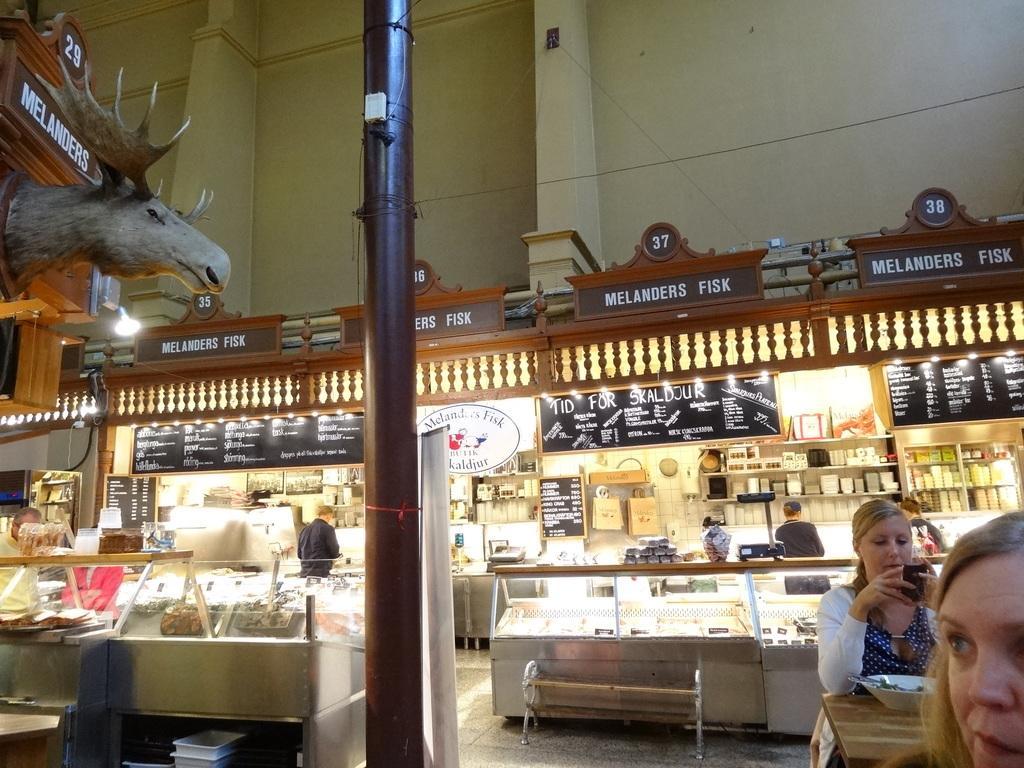Describe this image in one or two sentences. In this image I see a store and I see many things in these racks and I see boards on which there is something written and I see few things in these glass containers and I see 2 women over here in which this woman is sitting and holding a phone in her hands and I a pole over here and I see few more boards on which there are words and numbers written and I see the wall and I see the lights. 